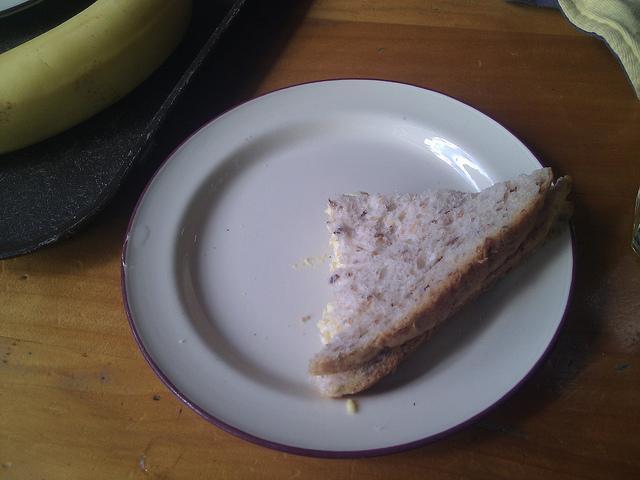Is the caption "The sandwich is touching the banana." a true representation of the image?
Answer yes or no. No. 